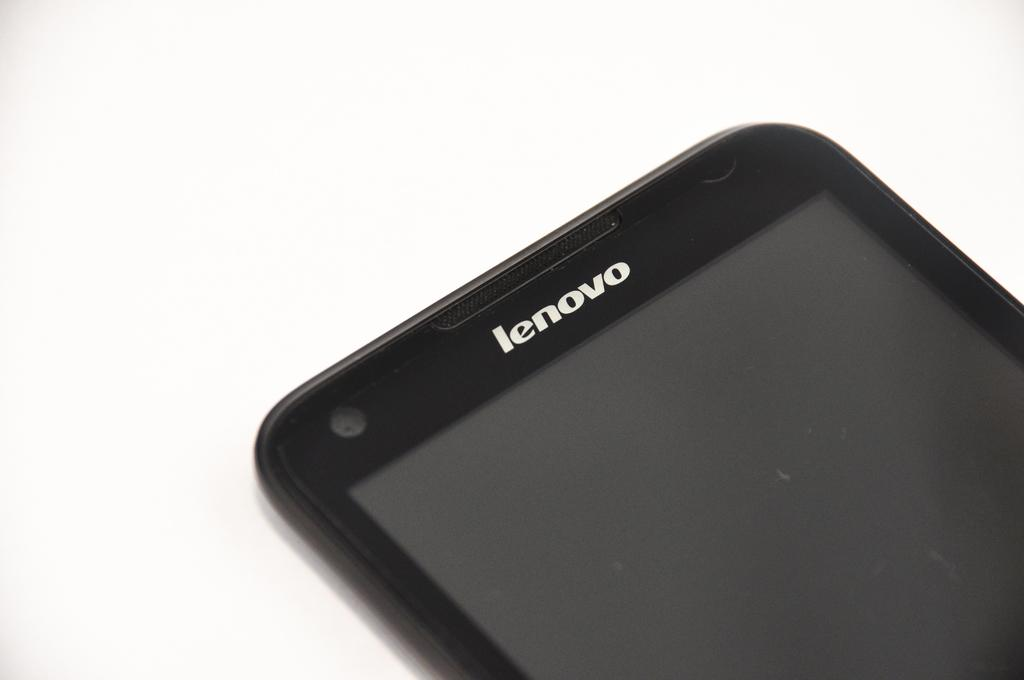<image>
Create a compact narrative representing the image presented. Lenovo is the brand shown on the top of this smart phone. 